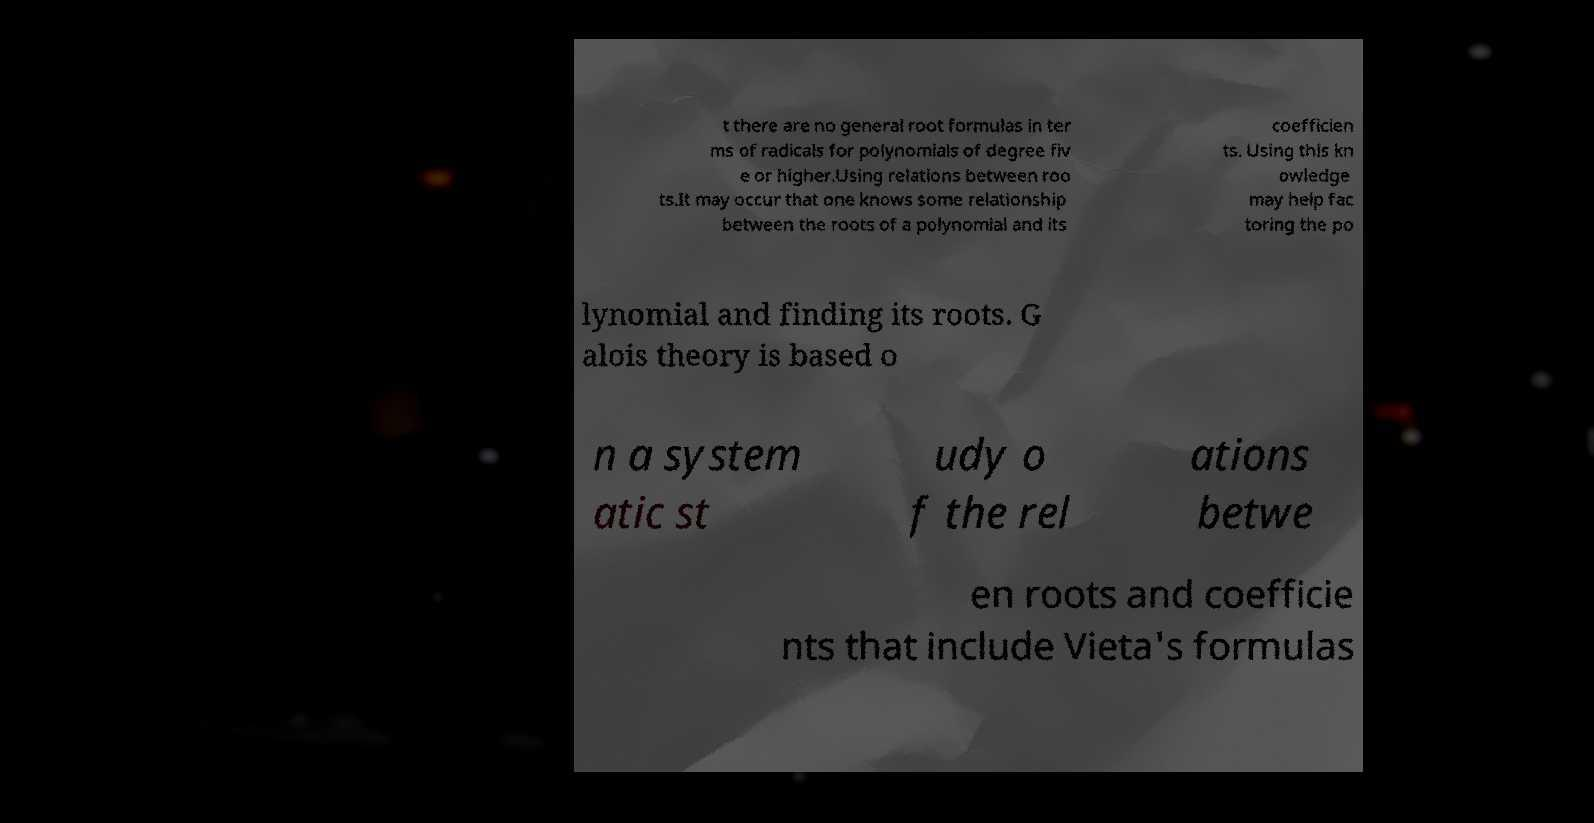Can you accurately transcribe the text from the provided image for me? t there are no general root formulas in ter ms of radicals for polynomials of degree fiv e or higher.Using relations between roo ts.It may occur that one knows some relationship between the roots of a polynomial and its coefficien ts. Using this kn owledge may help fac toring the po lynomial and finding its roots. G alois theory is based o n a system atic st udy o f the rel ations betwe en roots and coefficie nts that include Vieta's formulas 